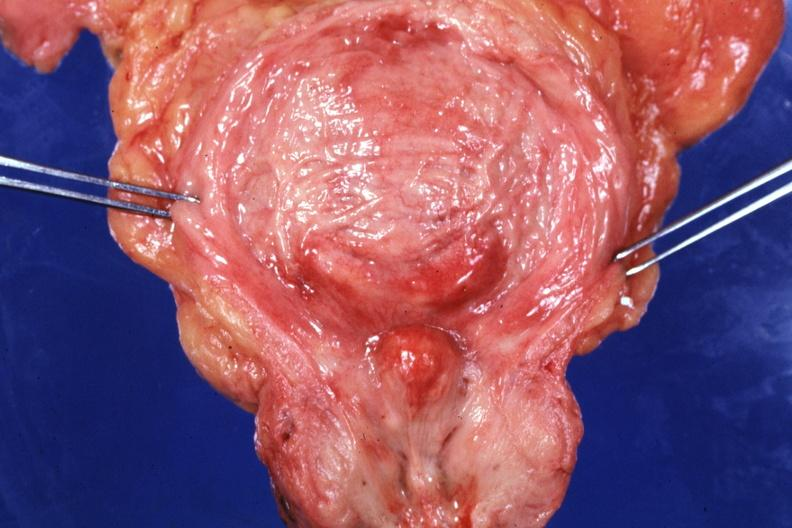s benign hyperplasia present?
Answer the question using a single word or phrase. Yes 